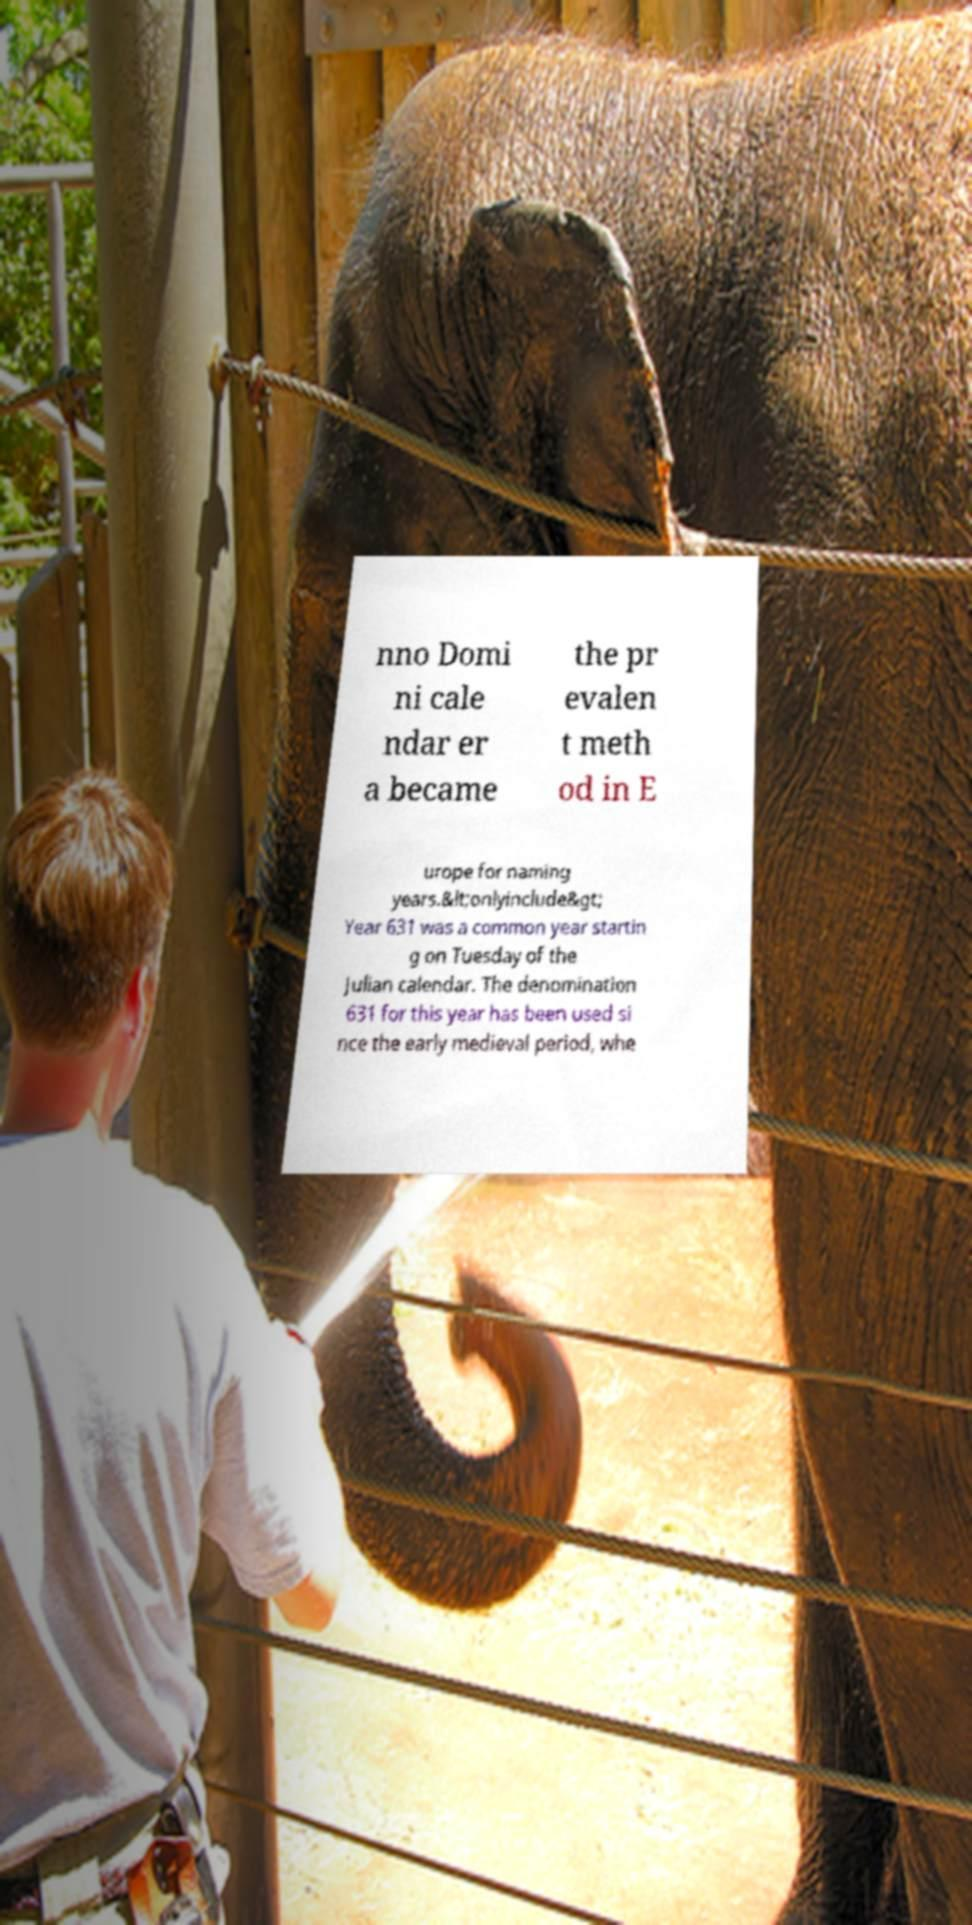Can you read and provide the text displayed in the image?This photo seems to have some interesting text. Can you extract and type it out for me? nno Domi ni cale ndar er a became the pr evalen t meth od in E urope for naming years.&lt;onlyinclude&gt; Year 631 was a common year startin g on Tuesday of the Julian calendar. The denomination 631 for this year has been used si nce the early medieval period, whe 